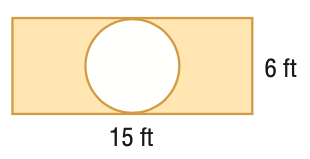Question: Find the area of the shaded region. Round to the nearest tenth.
Choices:
A. 61.7
B. 71.2
C. 90
D. 118.3
Answer with the letter. Answer: A 